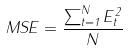<formula> <loc_0><loc_0><loc_500><loc_500>M S E = \frac { \sum _ { t = 1 } ^ { N } E _ { t } ^ { 2 } } { N }</formula> 